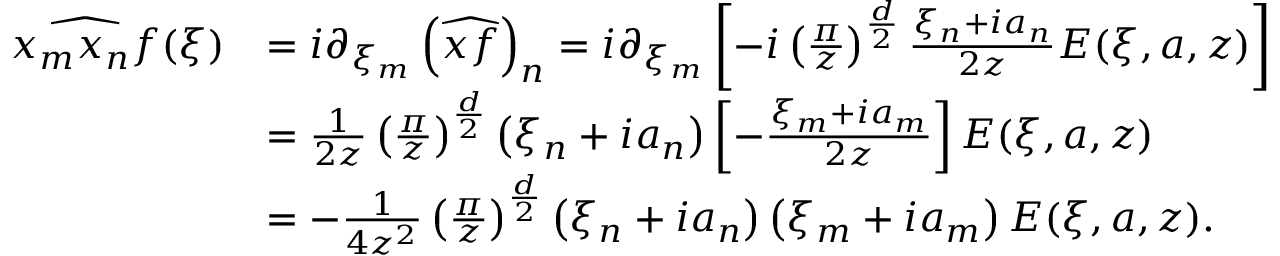<formula> <loc_0><loc_0><loc_500><loc_500>\begin{array} { r l } { \widehat { x _ { m } x _ { n } f } ( \xi ) } & { = i \partial _ { \xi _ { m } } \left ( \widehat { x f } \right ) _ { n } = i \partial _ { \xi _ { m } } \left [ - i \left ( \frac { \pi } { z } \right ) ^ { \frac { d } { 2 } } \frac { \xi _ { n } + i a _ { n } } { 2 z } E ( \xi , a , z ) \right ] } \\ & { = \frac { 1 } { 2 z } \left ( \frac { \pi } { z } \right ) ^ { \frac { d } { 2 } } \left ( \xi _ { n } + i a _ { n } \right ) \left [ - \frac { \xi _ { m } + i a _ { m } } { 2 z } \right ] E ( \xi , a , z ) } \\ & { = - \frac { 1 } { 4 z ^ { 2 } } \left ( \frac { \pi } { z } \right ) ^ { \frac { d } { 2 } } \left ( \xi _ { n } + i a _ { n } \right ) \left ( \xi _ { m } + i a _ { m } \right ) E ( \xi , a , z ) . } \end{array}</formula> 